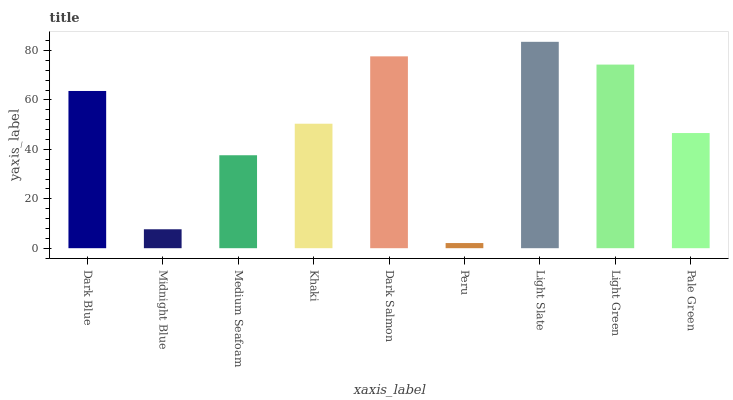Is Peru the minimum?
Answer yes or no. Yes. Is Light Slate the maximum?
Answer yes or no. Yes. Is Midnight Blue the minimum?
Answer yes or no. No. Is Midnight Blue the maximum?
Answer yes or no. No. Is Dark Blue greater than Midnight Blue?
Answer yes or no. Yes. Is Midnight Blue less than Dark Blue?
Answer yes or no. Yes. Is Midnight Blue greater than Dark Blue?
Answer yes or no. No. Is Dark Blue less than Midnight Blue?
Answer yes or no. No. Is Khaki the high median?
Answer yes or no. Yes. Is Khaki the low median?
Answer yes or no. Yes. Is Dark Blue the high median?
Answer yes or no. No. Is Medium Seafoam the low median?
Answer yes or no. No. 